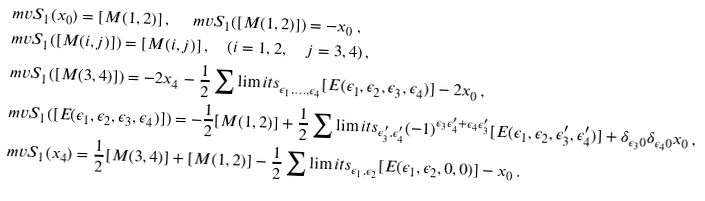Convert formula to latex. <formula><loc_0><loc_0><loc_500><loc_500>& \ m v S _ { 1 } ( x _ { 0 } ) = [ M ( 1 , 2 ) ] \, , \quad \ m v S _ { 1 } ( [ M ( 1 , 2 ) ] ) = - x _ { 0 } \, , \\ & \ m v S _ { 1 } ( [ M ( i , j ) ] ) = [ M ( i , j ) ] \, , \quad ( i = 1 , 2 , \quad j = 3 , 4 ) \, , \\ & \ m v S _ { 1 } ( [ M ( 3 , 4 ) ] ) = - 2 x _ { 4 } - \frac { 1 } { 2 } \sum \lim i t s _ { \epsilon _ { 1 } , \dots , \epsilon _ { 4 } } [ E ( \epsilon _ { 1 } , \epsilon _ { 2 } , \epsilon _ { 3 } , \epsilon _ { 4 } ) ] - 2 x _ { 0 } \, , \\ & \ m v S _ { 1 } ( [ E ( \epsilon _ { 1 } , \epsilon _ { 2 } , \epsilon _ { 3 } , \epsilon _ { 4 } ) ] ) = - \frac { 1 } { 2 } [ M ( 1 , 2 ) ] + \frac { 1 } { 2 } \sum \lim i t s _ { \epsilon _ { 3 } ^ { \prime } , \epsilon _ { 4 } ^ { \prime } } ( - 1 ) ^ { \epsilon _ { 3 } \epsilon _ { 4 } ^ { \prime } + \epsilon _ { 4 } \epsilon _ { 3 } ^ { \prime } } [ E ( \epsilon _ { 1 } , \epsilon _ { 2 } , \epsilon _ { 3 } ^ { \prime } , \epsilon _ { 4 } ^ { \prime } ) ] + \delta _ { \epsilon _ { 3 } 0 } \delta _ { \epsilon _ { 4 } 0 } x _ { 0 } \, , \\ & \ m v S _ { 1 } ( x _ { 4 } ) = \frac { 1 } { 2 } [ M ( 3 , 4 ) ] + [ M ( 1 , 2 ) ] - \frac { 1 } { 2 } \sum \lim i t s _ { \epsilon _ { 1 } , \epsilon _ { 2 } } [ E ( \epsilon _ { 1 } , \epsilon _ { 2 } , 0 , 0 ) ] - x _ { 0 } \, . \\</formula> 